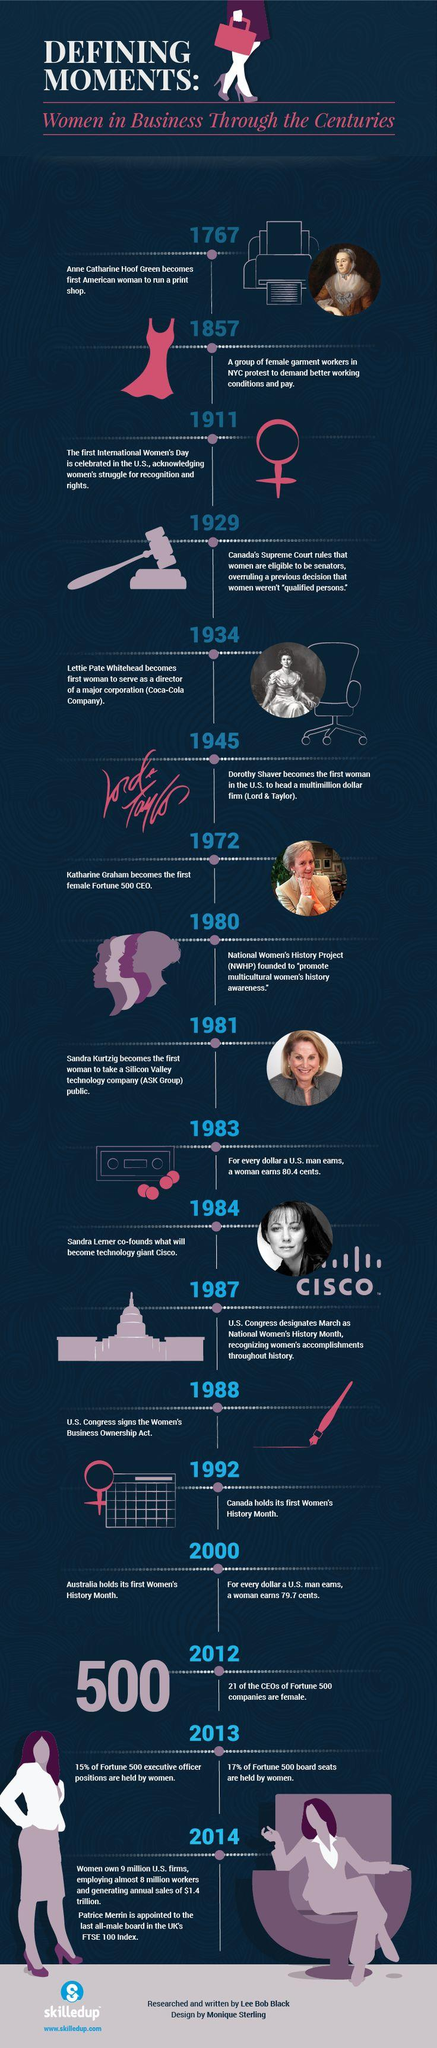Outline some significant characteristics in this image. Katharine Graham became the first female CEO of a Fortune 500 company in 1972. Sandra Lerner is the co-founder of Cisco Systems. The United States Congress signed the Women's Business Ownership Act in the year 1988. The first International Women's Day was celebrated in the United States in 1911. 